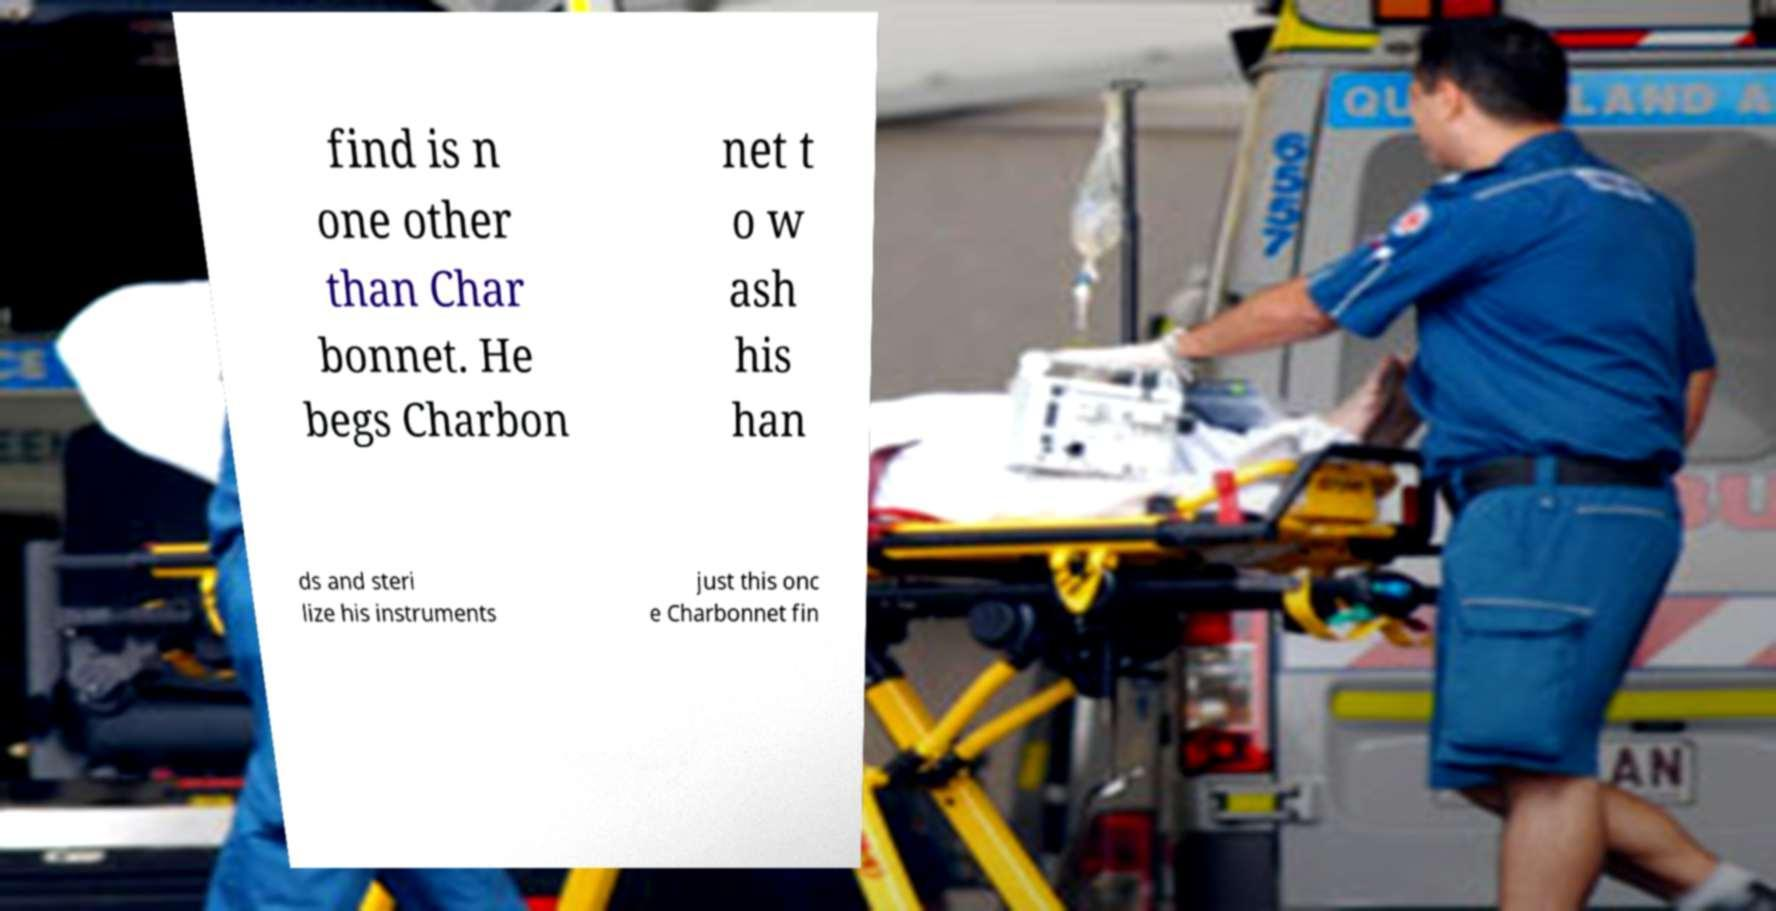What messages or text are displayed in this image? I need them in a readable, typed format. find is n one other than Char bonnet. He begs Charbon net t o w ash his han ds and steri lize his instruments just this onc e Charbonnet fin 